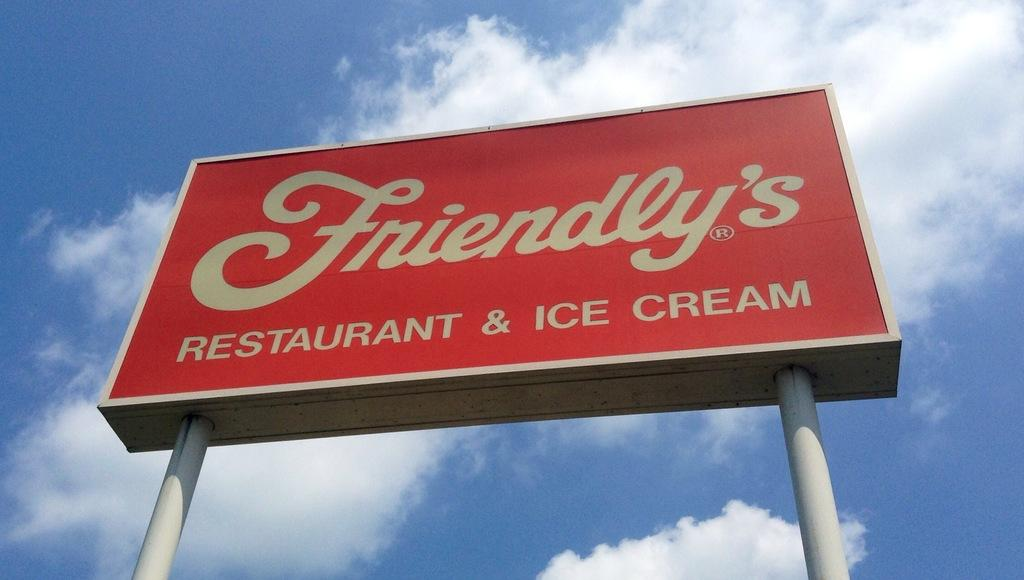<image>
Share a concise interpretation of the image provided. The Friendly's Restaurant & Ice Cream sign is red. 